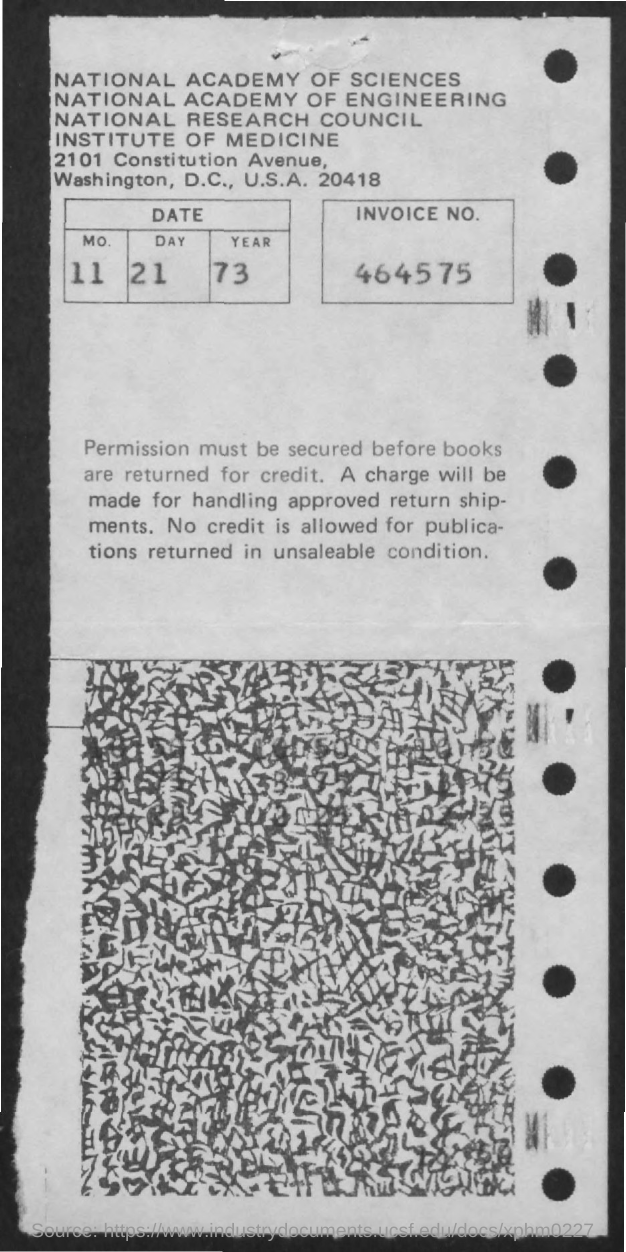Point out several critical features in this image. What is the invoice number provided in the document? It is 464575... The date mentioned in this document is 11-21-73. 